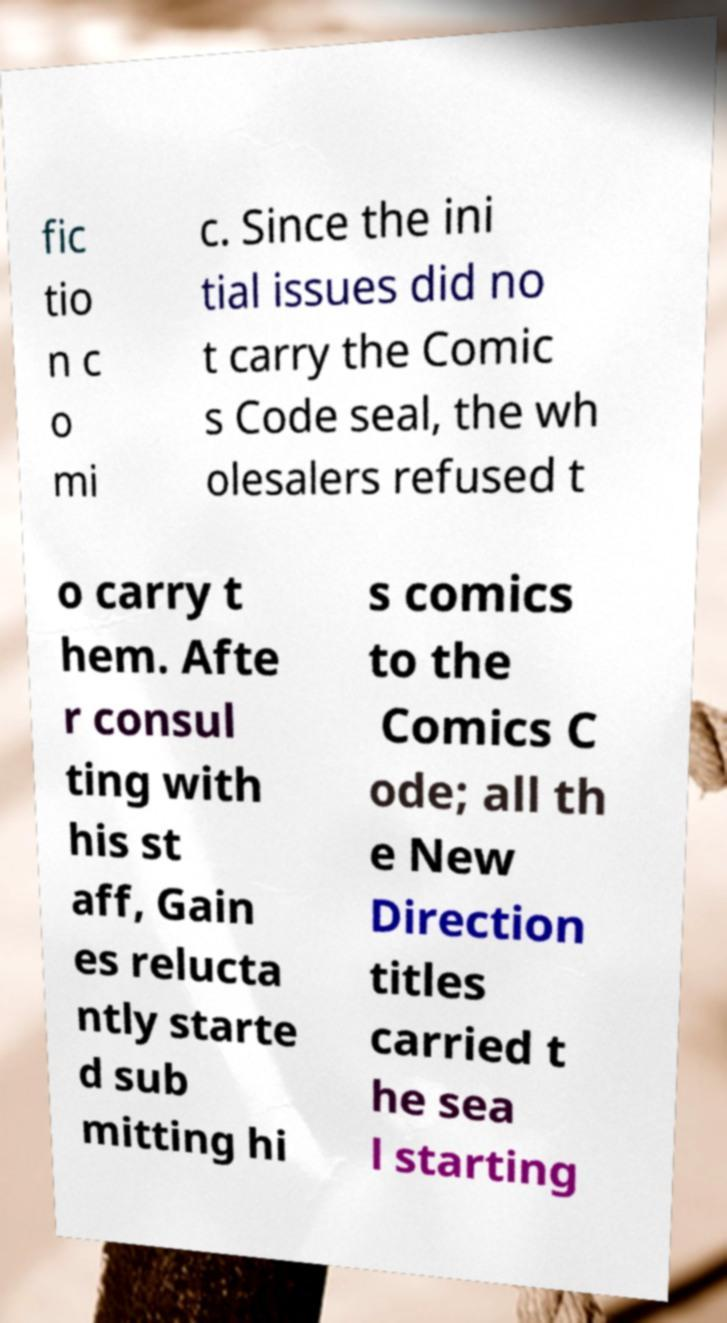Could you assist in decoding the text presented in this image and type it out clearly? fic tio n c o mi c. Since the ini tial issues did no t carry the Comic s Code seal, the wh olesalers refused t o carry t hem. Afte r consul ting with his st aff, Gain es relucta ntly starte d sub mitting hi s comics to the Comics C ode; all th e New Direction titles carried t he sea l starting 